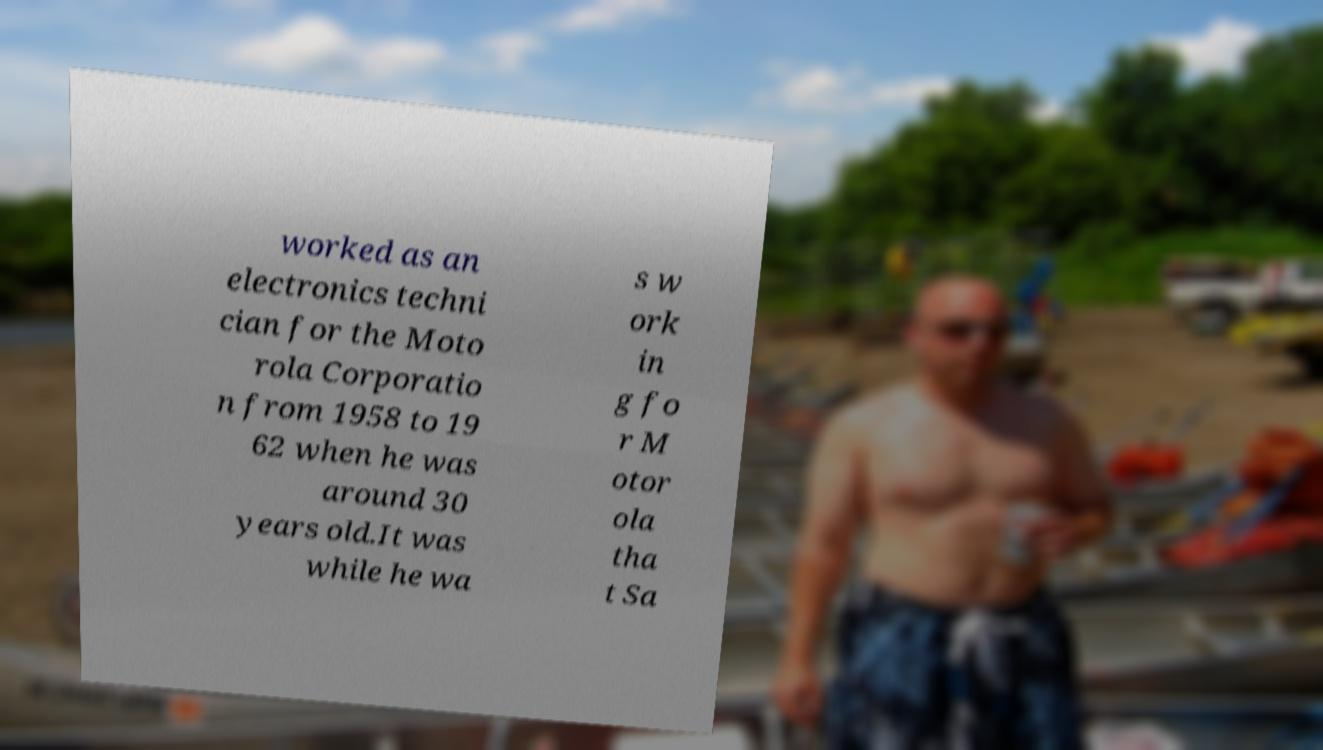For documentation purposes, I need the text within this image transcribed. Could you provide that? worked as an electronics techni cian for the Moto rola Corporatio n from 1958 to 19 62 when he was around 30 years old.It was while he wa s w ork in g fo r M otor ola tha t Sa 